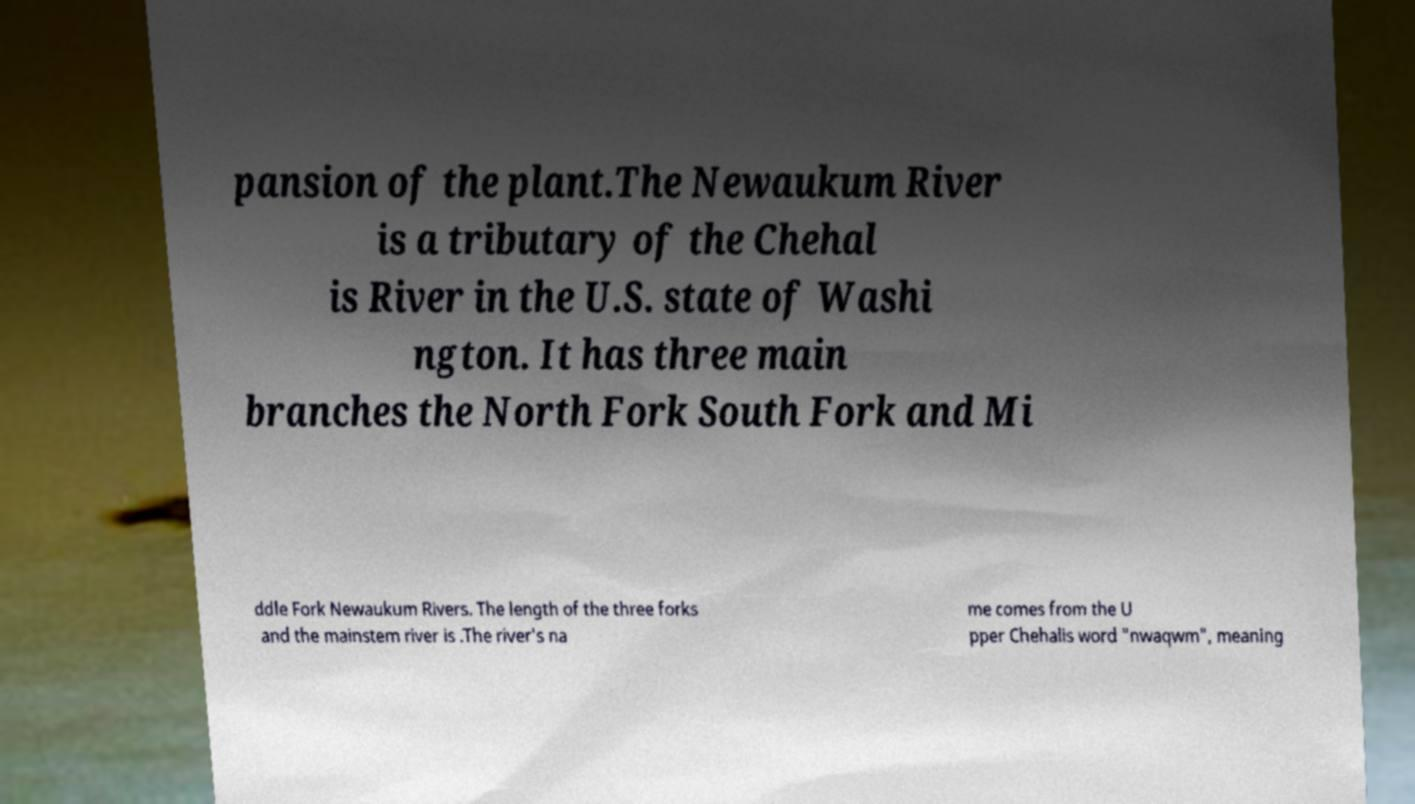What messages or text are displayed in this image? I need them in a readable, typed format. pansion of the plant.The Newaukum River is a tributary of the Chehal is River in the U.S. state of Washi ngton. It has three main branches the North Fork South Fork and Mi ddle Fork Newaukum Rivers. The length of the three forks and the mainstem river is .The river's na me comes from the U pper Chehalis word "nwaqwm", meaning 